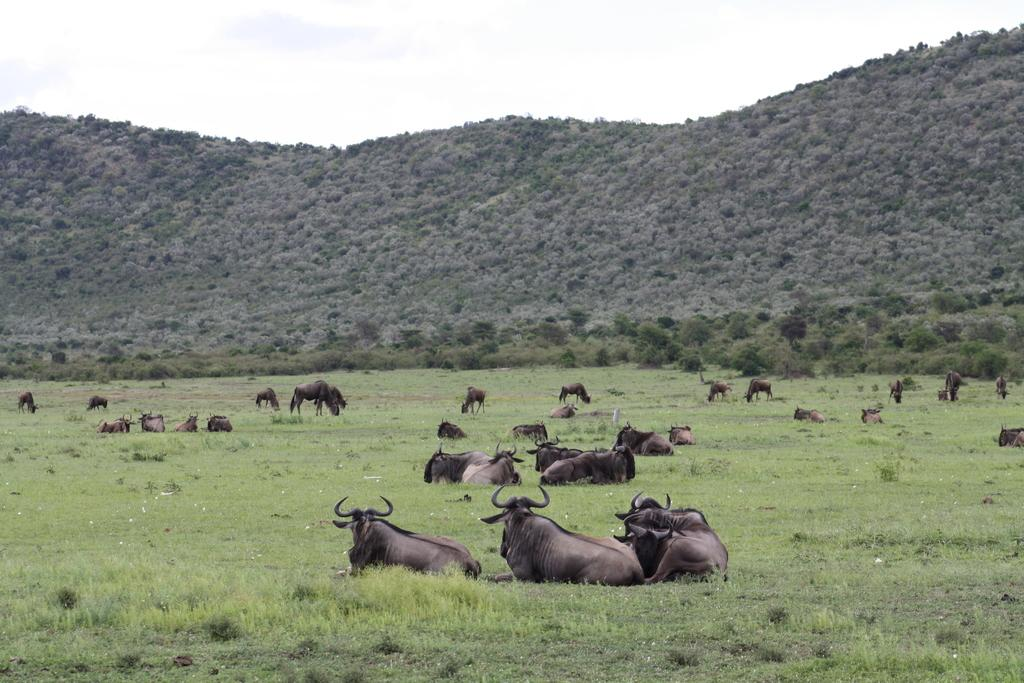What is the main subject of the image? The main subject of the image is many animals. What colors are the animals in the image? The animals are in brown and black colors. What are the animals doing in the image? Some animals are sitting, while others are standing. What can be seen in the background of the image? There are trees and the sky visible in the background of the image. What color are the trees in the image? The trees are green in color. What color is the sky in the image? The sky is white in color. What type of popcorn is being served to the animals in the image? There is no popcorn present in the image; it features animals in brown and black colors, with some sitting and others standing. Can you tell me how many yokes are attached to the animals in the image? There are no yokes attached to the animals in the image; they are depicted in their natural state. 